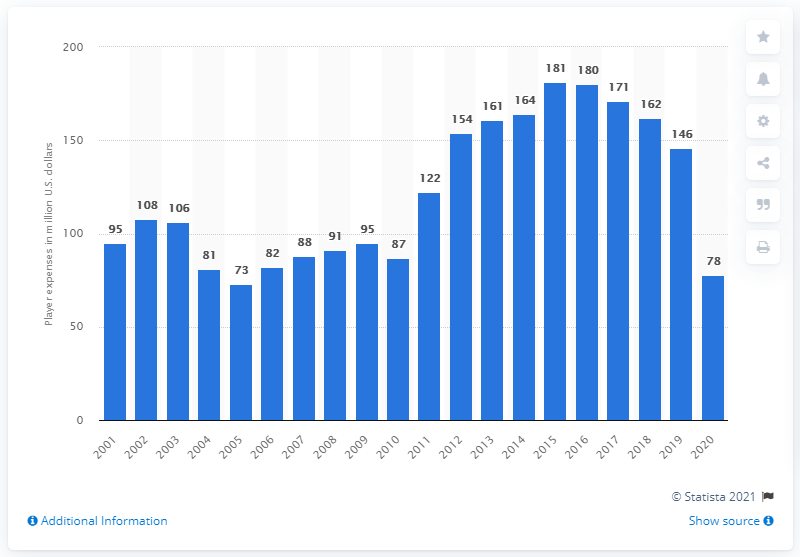Give some essential details in this illustration. The payroll of the Texas Rangers in 2020 was $78 million. 